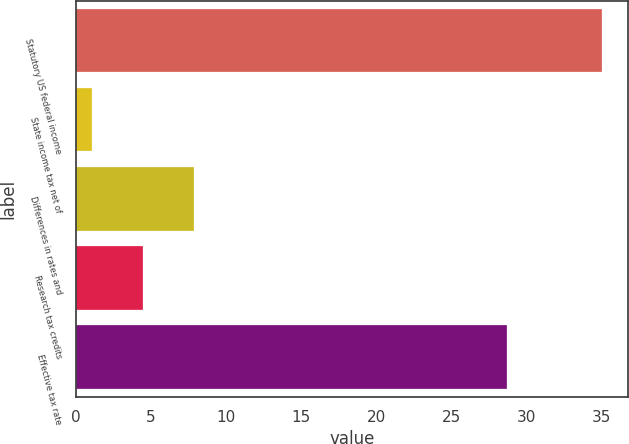Convert chart to OTSL. <chart><loc_0><loc_0><loc_500><loc_500><bar_chart><fcel>Statutory US federal income<fcel>State income tax net of<fcel>Differences in rates and<fcel>Research tax credits<fcel>Effective tax rate<nl><fcel>35<fcel>1.1<fcel>7.88<fcel>4.49<fcel>28.7<nl></chart> 